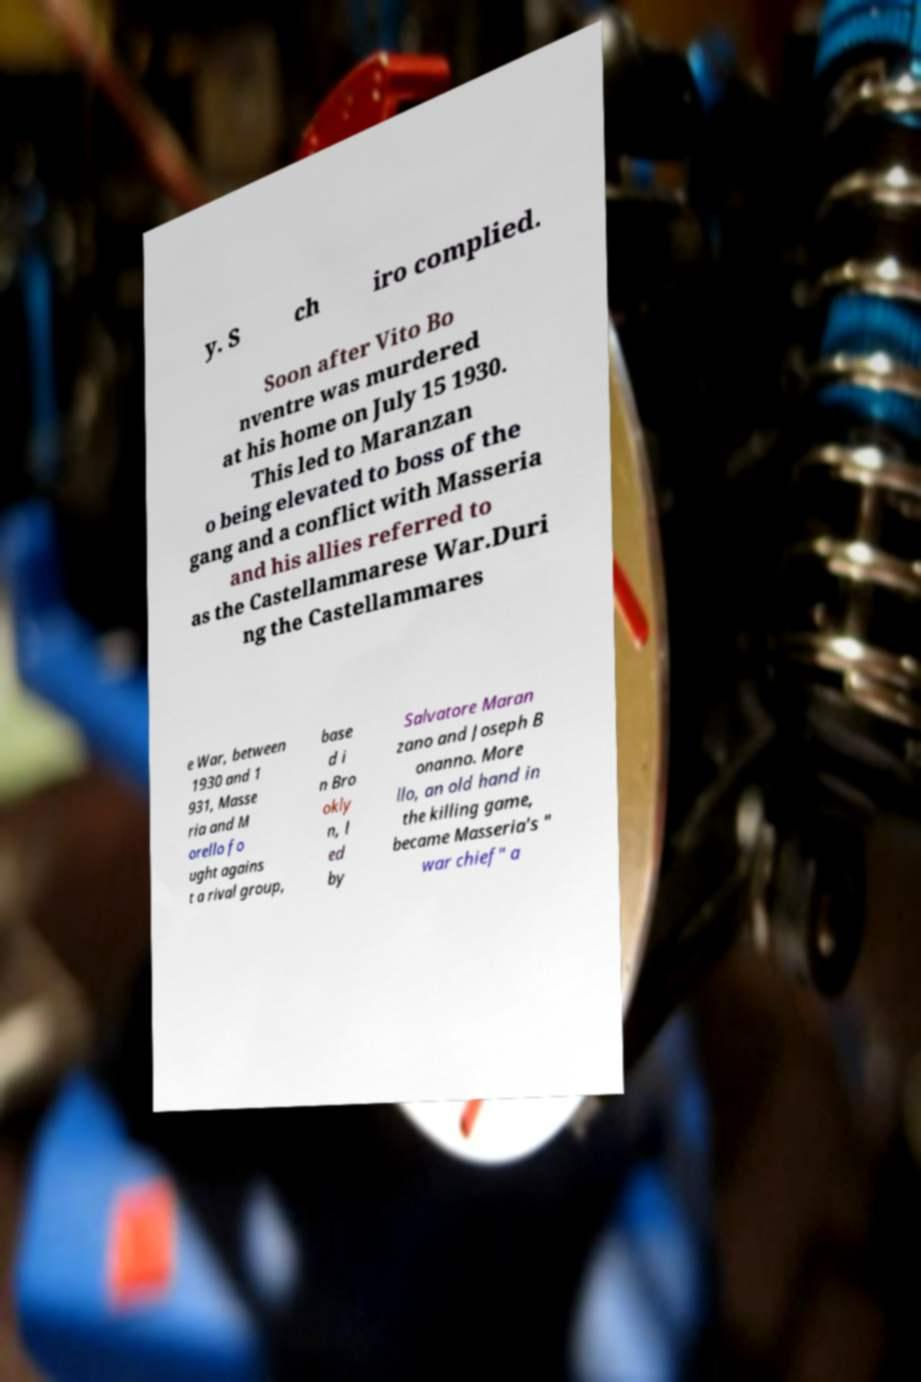Could you extract and type out the text from this image? y. S ch iro complied. Soon after Vito Bo nventre was murdered at his home on July 15 1930. This led to Maranzan o being elevated to boss of the gang and a conflict with Masseria and his allies referred to as the Castellammarese War.Duri ng the Castellammares e War, between 1930 and 1 931, Masse ria and M orello fo ught agains t a rival group, base d i n Bro okly n, l ed by Salvatore Maran zano and Joseph B onanno. More llo, an old hand in the killing game, became Masseria's " war chief" a 